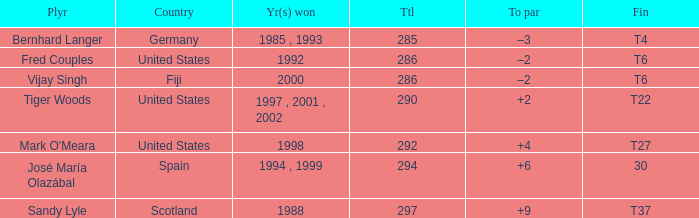Which player has a total of more than 290 and +4 to par. Mark O'Meara. 